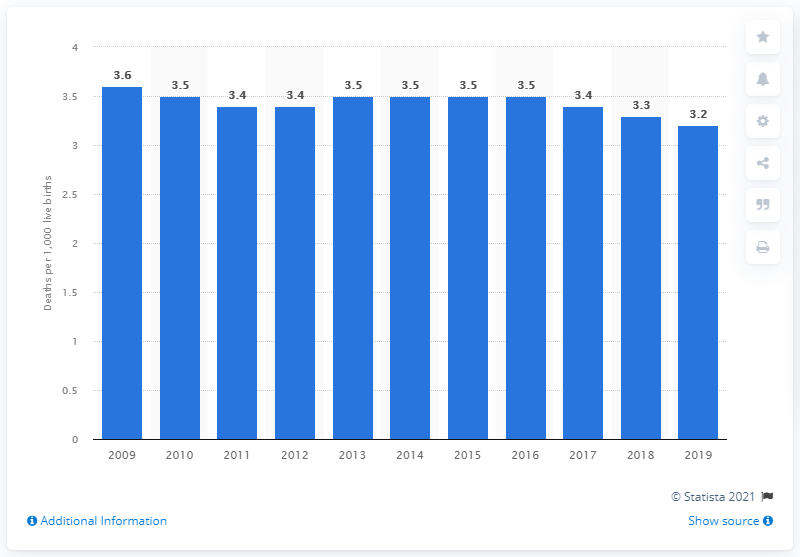Point out several critical features in this image. The infant mortality rate in Denmark in 2019 was 3.2 per 1,000 live births. 